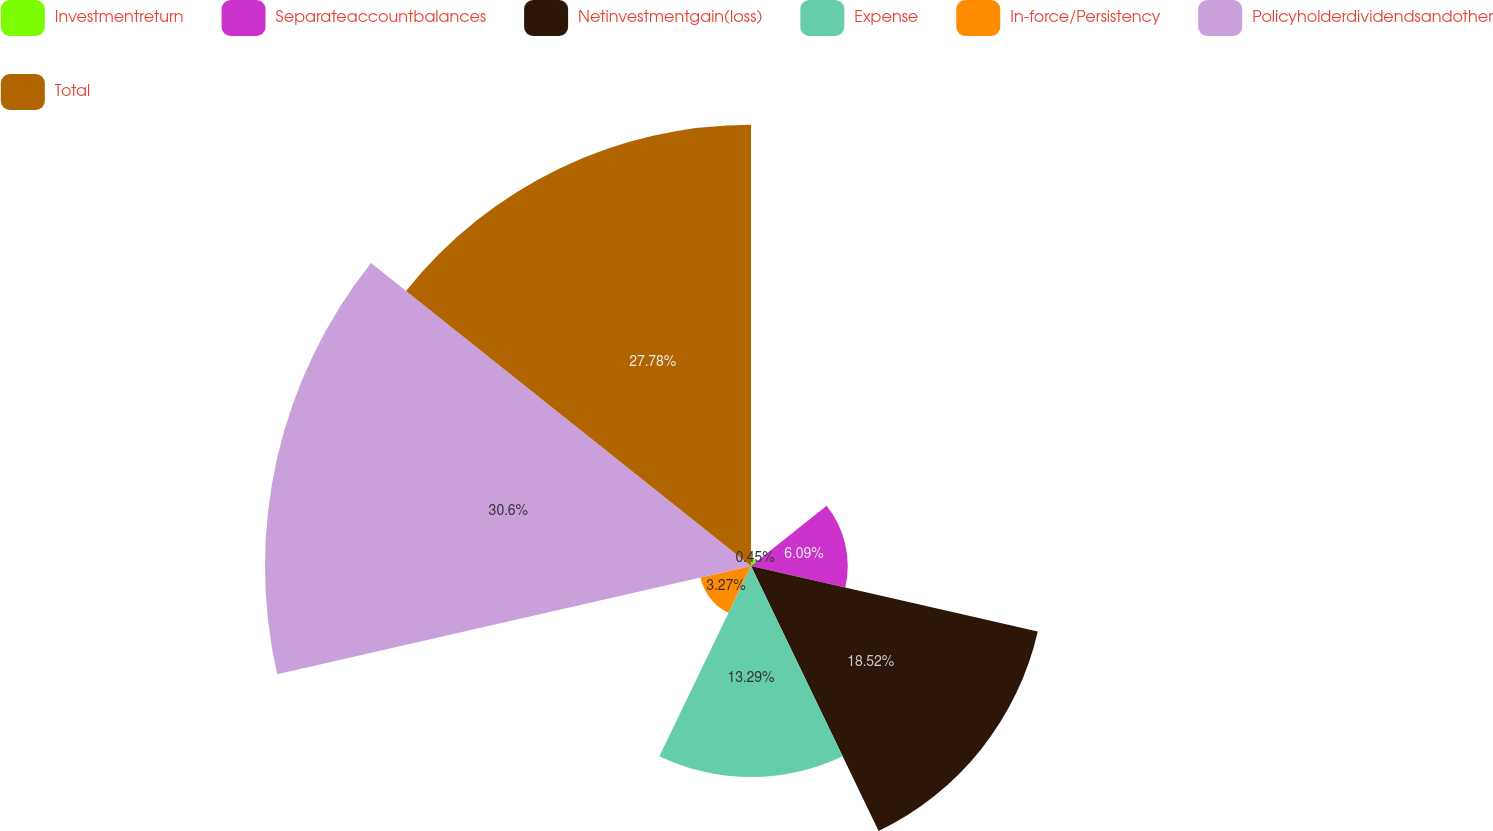Convert chart to OTSL. <chart><loc_0><loc_0><loc_500><loc_500><pie_chart><fcel>Investmentreturn<fcel>Separateaccountbalances<fcel>Netinvestmentgain(loss)<fcel>Expense<fcel>In-force/Persistency<fcel>Policyholderdividendsandother<fcel>Total<nl><fcel>0.45%<fcel>6.09%<fcel>18.52%<fcel>13.29%<fcel>3.27%<fcel>30.6%<fcel>27.78%<nl></chart> 